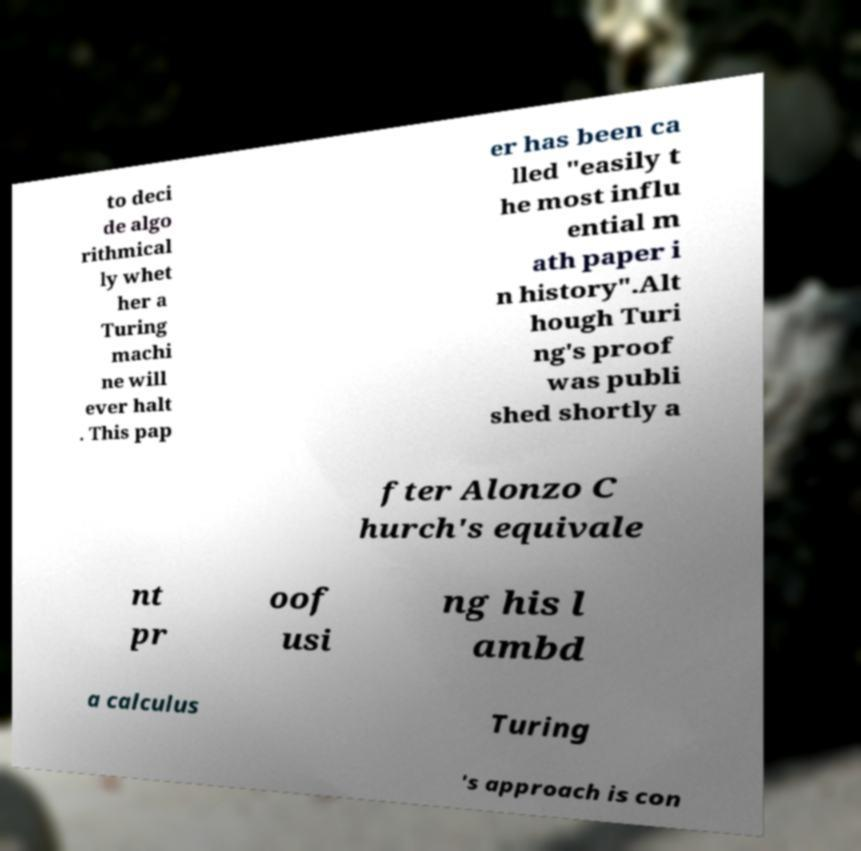Please read and relay the text visible in this image. What does it say? to deci de algo rithmical ly whet her a Turing machi ne will ever halt . This pap er has been ca lled "easily t he most influ ential m ath paper i n history".Alt hough Turi ng's proof was publi shed shortly a fter Alonzo C hurch's equivale nt pr oof usi ng his l ambd a calculus Turing 's approach is con 